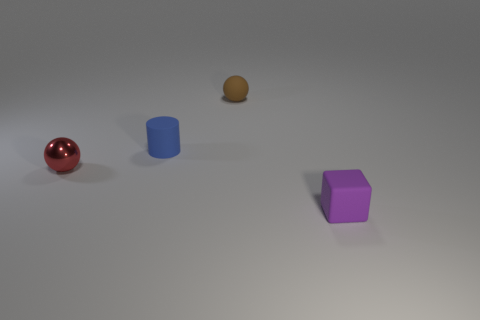Subtract 0 purple cylinders. How many objects are left? 4 Subtract all cubes. How many objects are left? 3 Subtract 1 cylinders. How many cylinders are left? 0 Subtract all brown cubes. Subtract all purple cylinders. How many cubes are left? 1 Subtract all brown cylinders. How many blue cubes are left? 0 Subtract all small brown cubes. Subtract all red metal objects. How many objects are left? 3 Add 2 small red metallic objects. How many small red metallic objects are left? 3 Add 3 small metallic balls. How many small metallic balls exist? 4 Add 4 brown things. How many objects exist? 8 Subtract all red balls. How many balls are left? 1 